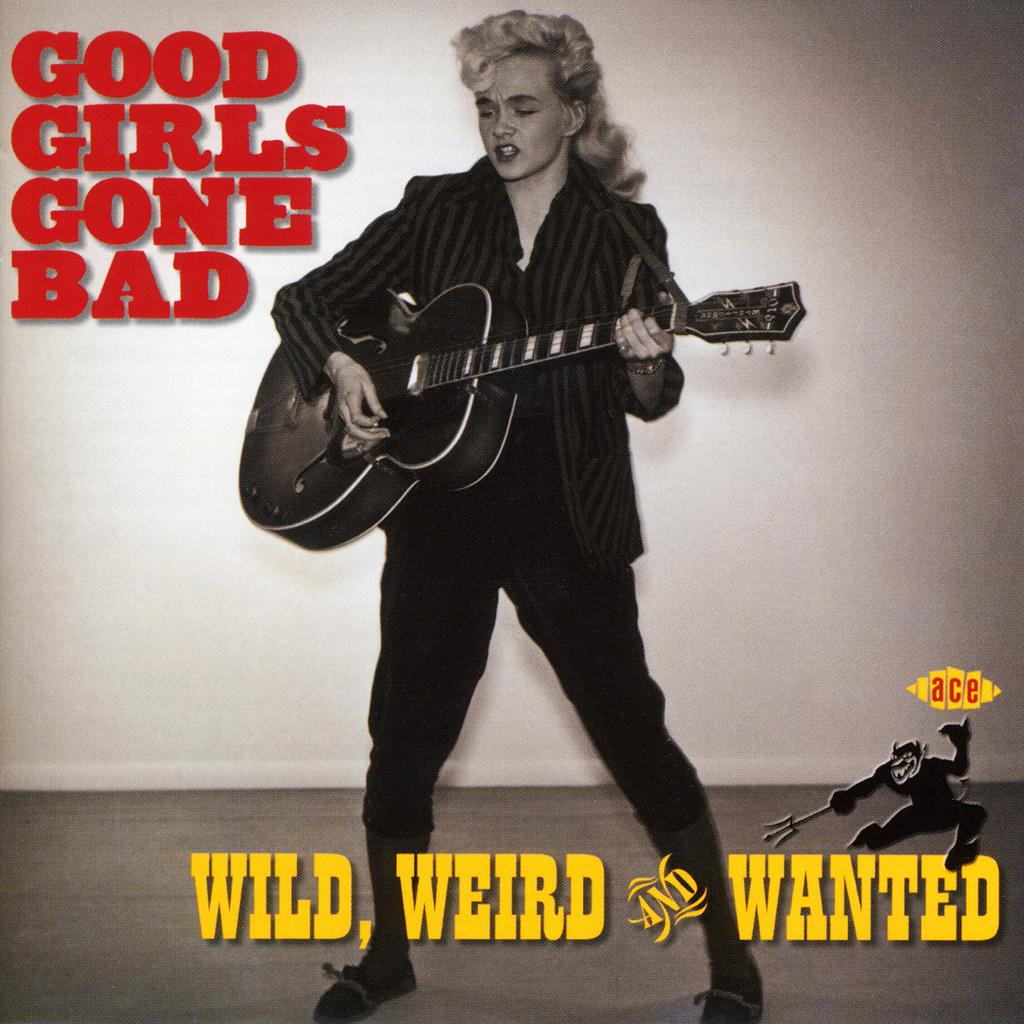What is the person in the image holding? The person is holding a guitar. What is the person doing with the guitar? The person is playing the guitar. What other activity is the person engaged in? The person is singing. What else can be seen in the image besides the person and the guitar? There is a poster in the image. Can you tell me how many women are present in the image? There is no mention of a woman in the image; it features a person playing a guitar and singing. Is there a camp visible in the image? There is no camp present in the image. 